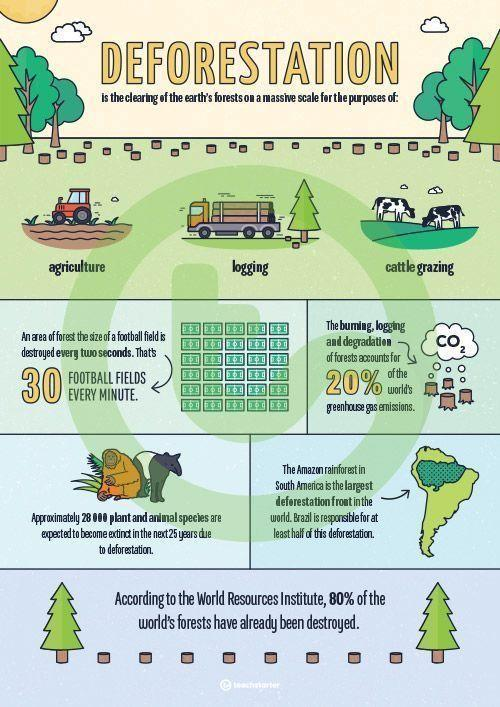What are the three main reasons for deforestation?
Answer the question with a short phrase. agriculture, logging, cattle grazing 